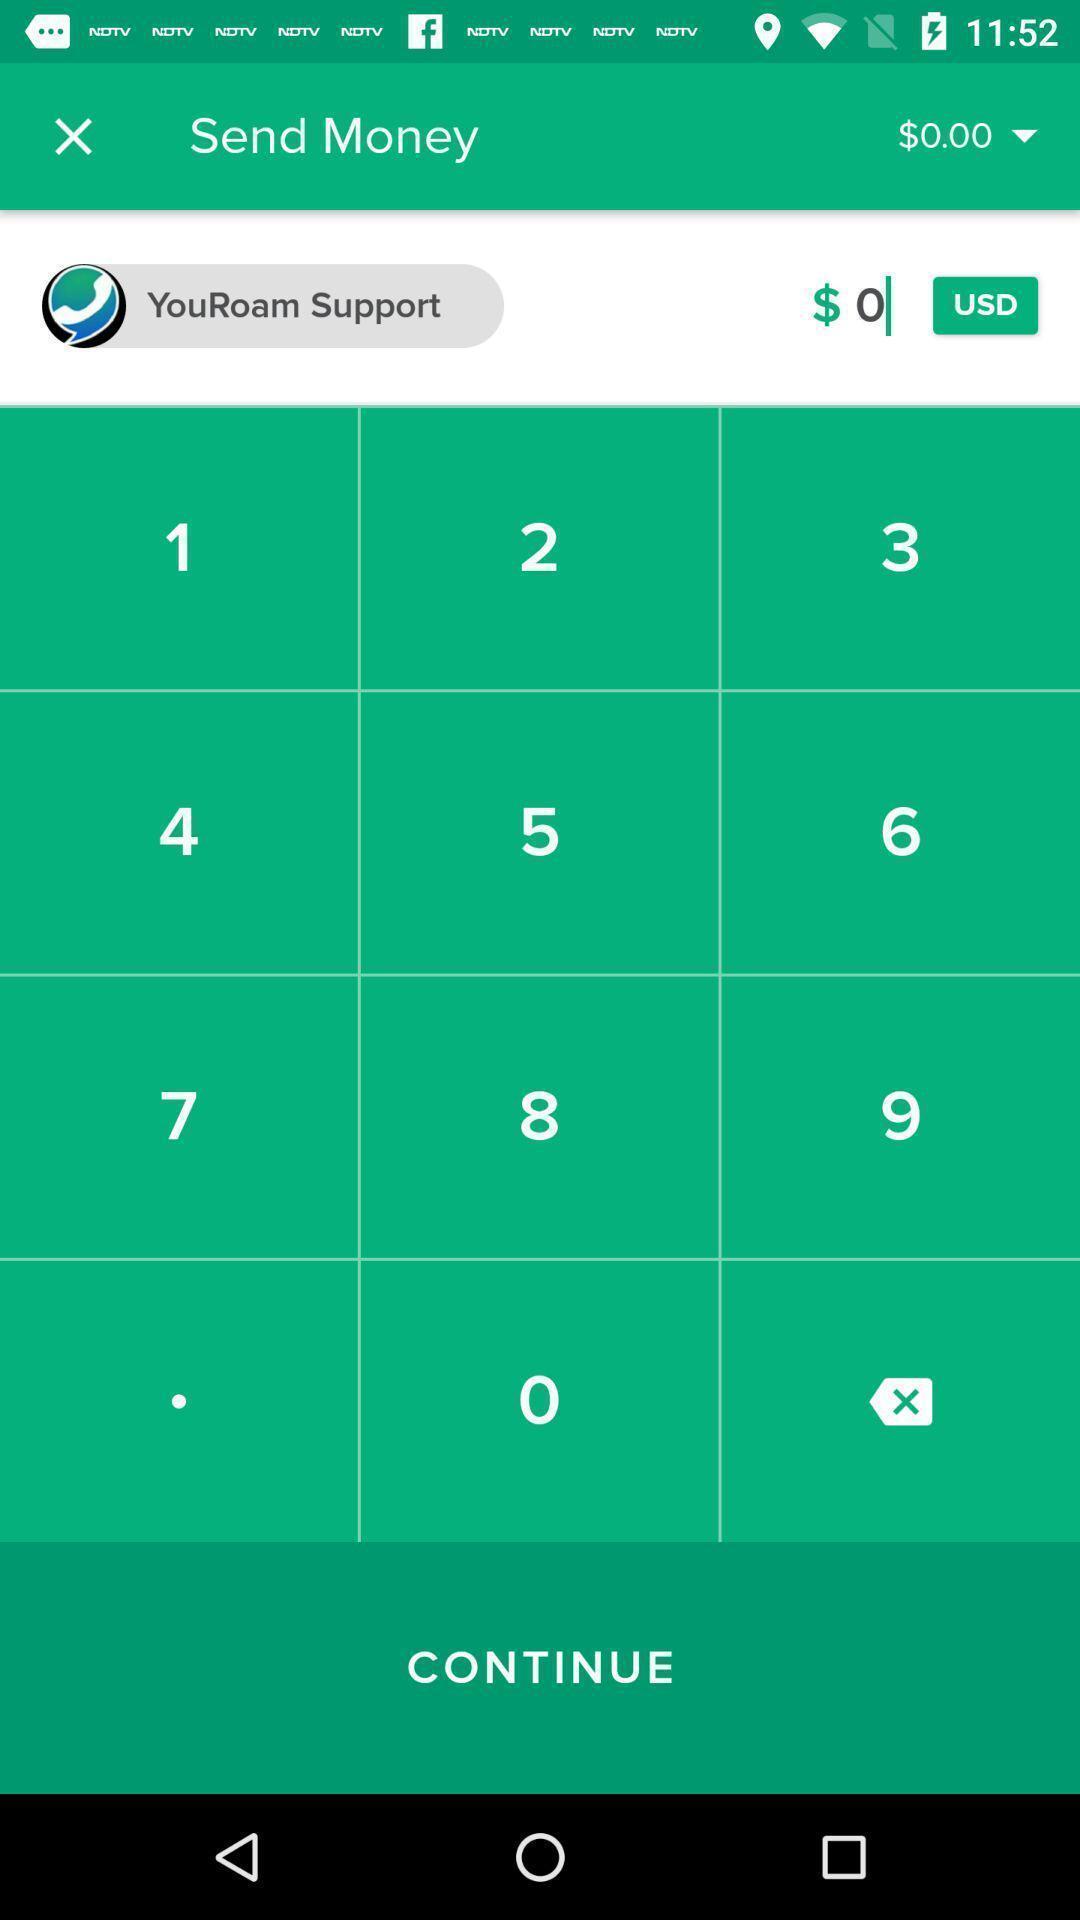Summarize the information in this screenshot. Screen displaying numbers and amount option with currency. 